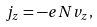Convert formula to latex. <formula><loc_0><loc_0><loc_500><loc_500>j _ { z } = - e N v _ { z } ,</formula> 